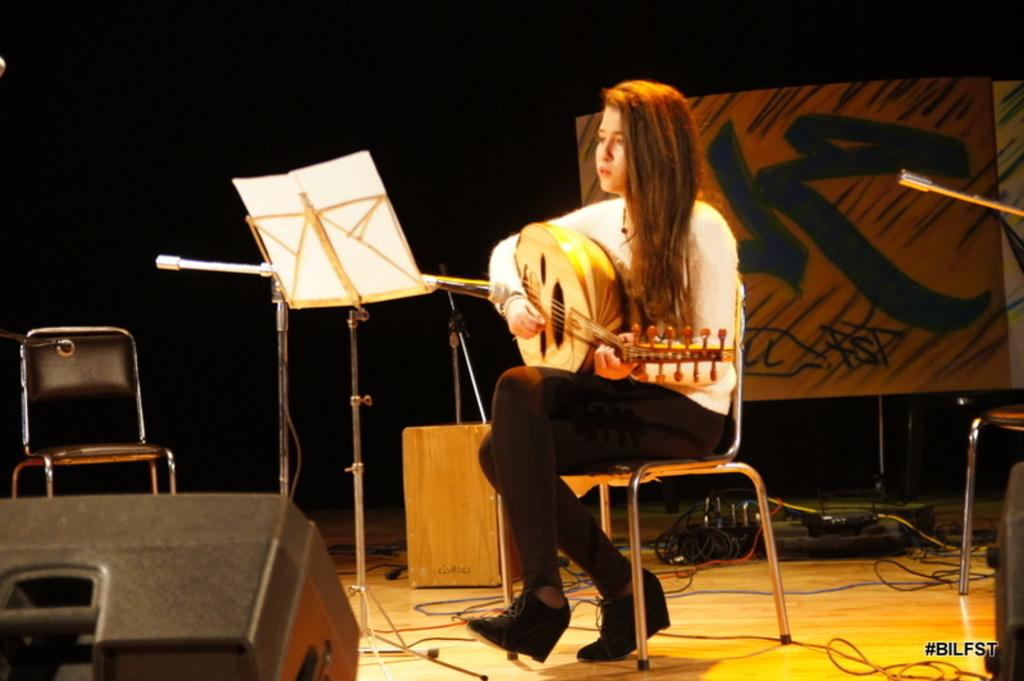What is the main subject of the image? There is a woman in the image. What is the woman doing in the image? The woman is sitting on a chair and holding a guitar. What is the woman looking at in the image? The woman is looking at a paper. What furniture is present in the image? There is a chair in the image. What electronic device is present in the image? There is a speaker in the image. What additional items can be seen in the image? There are cables in the image. What type of jewel can be seen on the woman's neck in the image? There is no jewel visible on the woman's neck in the image. What does the park smell like in the image? There is no park present in the image, so it is not possible to determine the smell. 